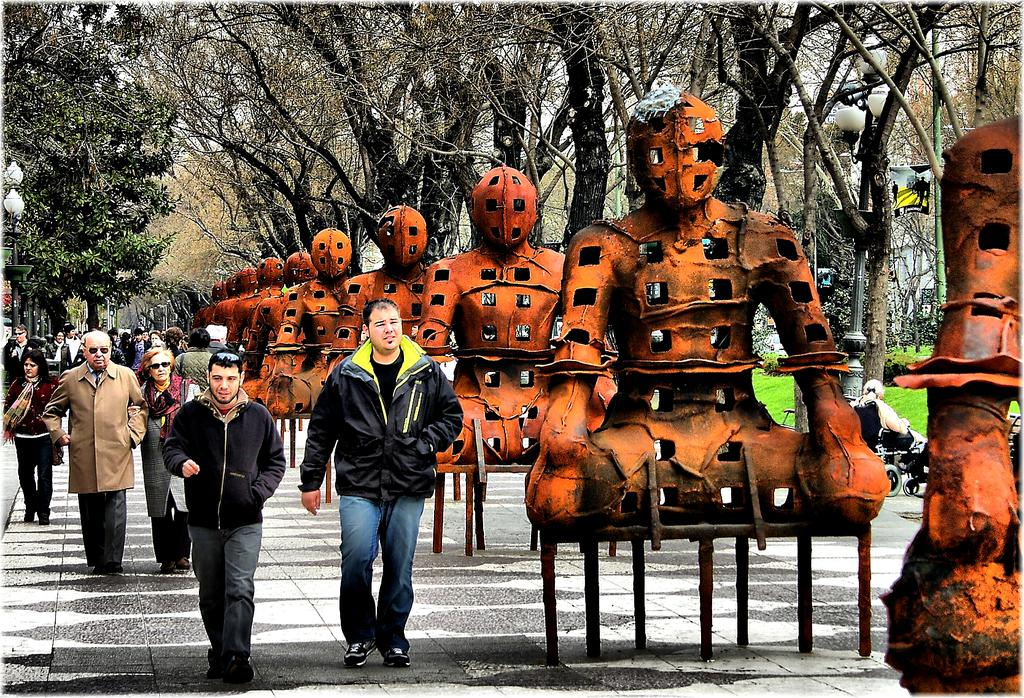What are the people in the image doing? The people in the image are walking on a path. What can be seen beside the people? There are statues beside the people. What else is present beside the statues? There are trees beside the statues. What type of rhythm can be heard from the branch in the image? There is no branch present in the image, and therefore no rhythm can be heard from it. 